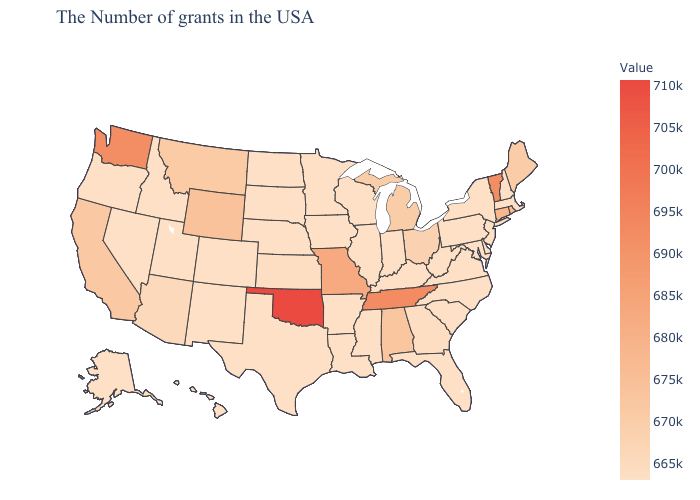Among the states that border Kansas , does Nebraska have the lowest value?
Answer briefly. Yes. Among the states that border Arkansas , which have the lowest value?
Write a very short answer. Mississippi, Louisiana, Texas. Which states hav the highest value in the MidWest?
Be succinct. Missouri. Among the states that border Mississippi , does Tennessee have the lowest value?
Concise answer only. No. Which states have the lowest value in the MidWest?
Answer briefly. Indiana, Wisconsin, Illinois, Minnesota, Iowa, Nebraska, South Dakota, North Dakota. Does Nebraska have a higher value than Oklahoma?
Be succinct. No. 